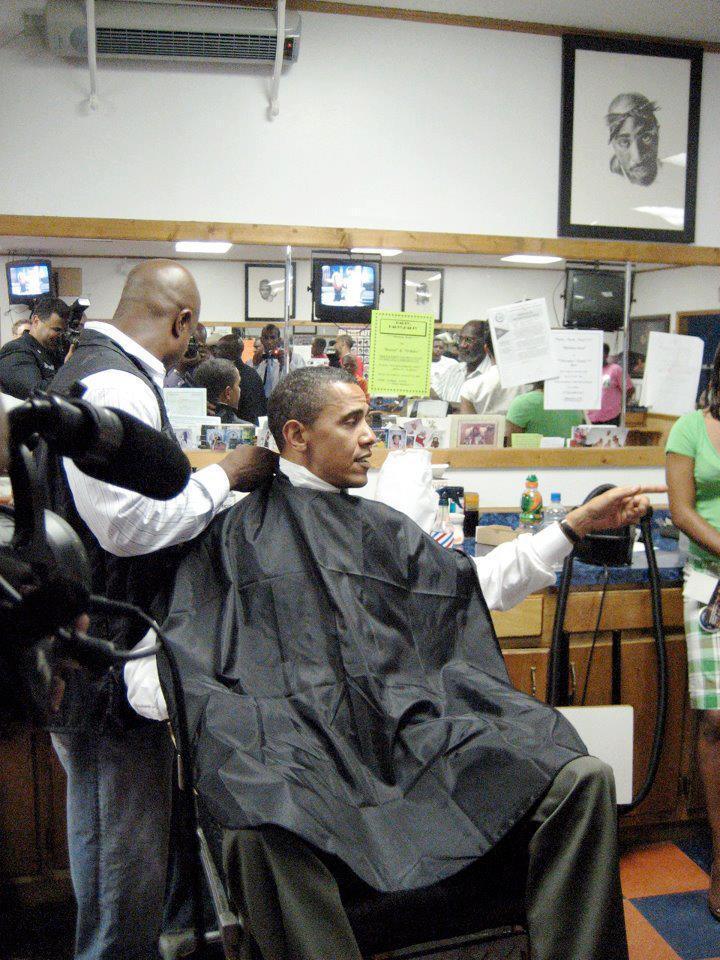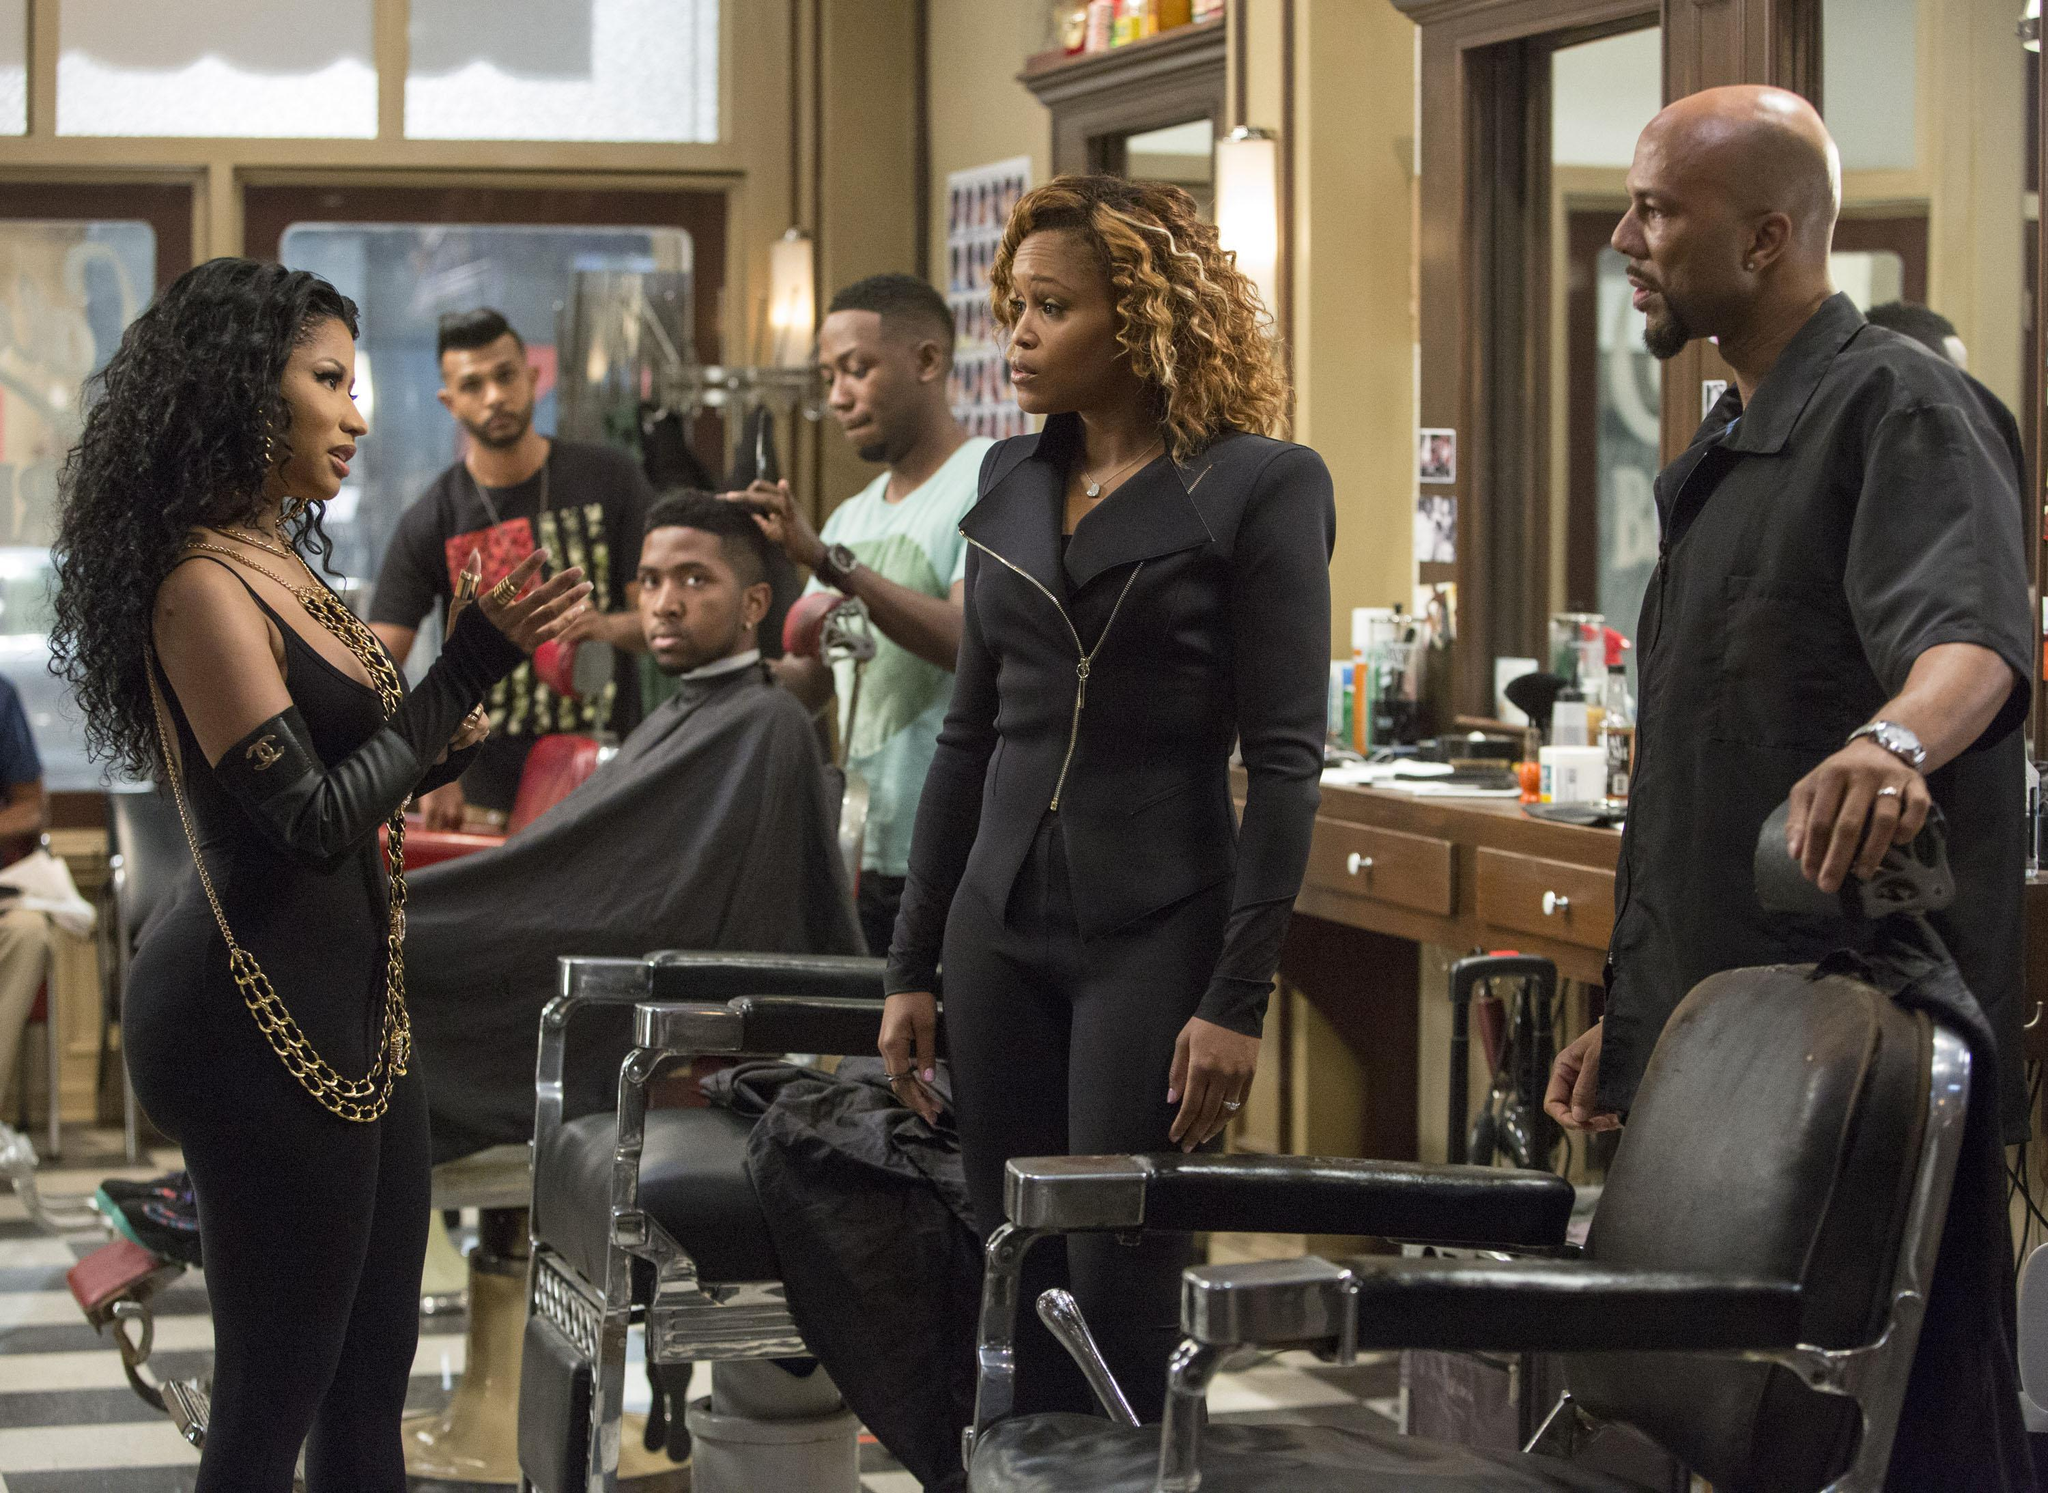The first image is the image on the left, the second image is the image on the right. For the images displayed, is the sentence "A barber is working on a former US president in one of the images" factually correct? Answer yes or no. Yes. 